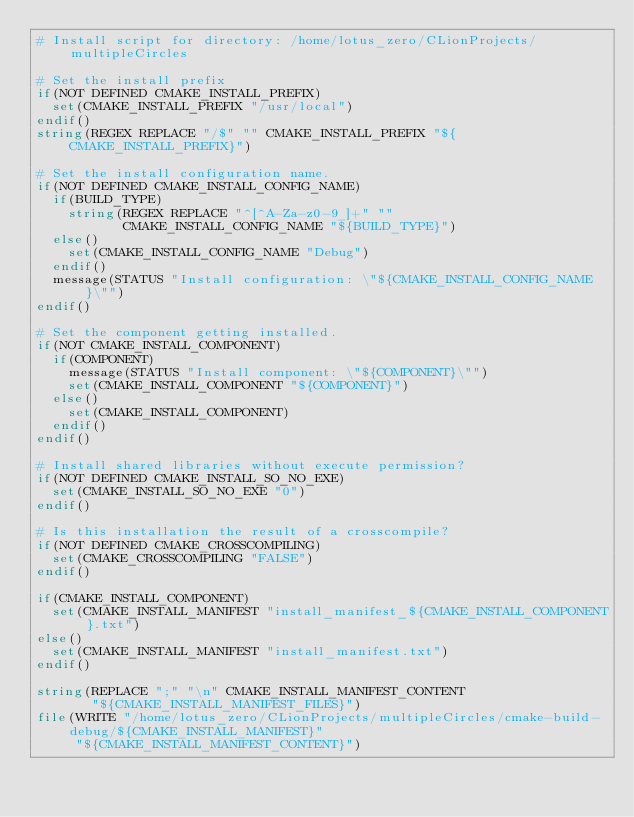Convert code to text. <code><loc_0><loc_0><loc_500><loc_500><_CMake_># Install script for directory: /home/lotus_zero/CLionProjects/multipleCircles

# Set the install prefix
if(NOT DEFINED CMAKE_INSTALL_PREFIX)
  set(CMAKE_INSTALL_PREFIX "/usr/local")
endif()
string(REGEX REPLACE "/$" "" CMAKE_INSTALL_PREFIX "${CMAKE_INSTALL_PREFIX}")

# Set the install configuration name.
if(NOT DEFINED CMAKE_INSTALL_CONFIG_NAME)
  if(BUILD_TYPE)
    string(REGEX REPLACE "^[^A-Za-z0-9_]+" ""
           CMAKE_INSTALL_CONFIG_NAME "${BUILD_TYPE}")
  else()
    set(CMAKE_INSTALL_CONFIG_NAME "Debug")
  endif()
  message(STATUS "Install configuration: \"${CMAKE_INSTALL_CONFIG_NAME}\"")
endif()

# Set the component getting installed.
if(NOT CMAKE_INSTALL_COMPONENT)
  if(COMPONENT)
    message(STATUS "Install component: \"${COMPONENT}\"")
    set(CMAKE_INSTALL_COMPONENT "${COMPONENT}")
  else()
    set(CMAKE_INSTALL_COMPONENT)
  endif()
endif()

# Install shared libraries without execute permission?
if(NOT DEFINED CMAKE_INSTALL_SO_NO_EXE)
  set(CMAKE_INSTALL_SO_NO_EXE "0")
endif()

# Is this installation the result of a crosscompile?
if(NOT DEFINED CMAKE_CROSSCOMPILING)
  set(CMAKE_CROSSCOMPILING "FALSE")
endif()

if(CMAKE_INSTALL_COMPONENT)
  set(CMAKE_INSTALL_MANIFEST "install_manifest_${CMAKE_INSTALL_COMPONENT}.txt")
else()
  set(CMAKE_INSTALL_MANIFEST "install_manifest.txt")
endif()

string(REPLACE ";" "\n" CMAKE_INSTALL_MANIFEST_CONTENT
       "${CMAKE_INSTALL_MANIFEST_FILES}")
file(WRITE "/home/lotus_zero/CLionProjects/multipleCircles/cmake-build-debug/${CMAKE_INSTALL_MANIFEST}"
     "${CMAKE_INSTALL_MANIFEST_CONTENT}")
</code> 